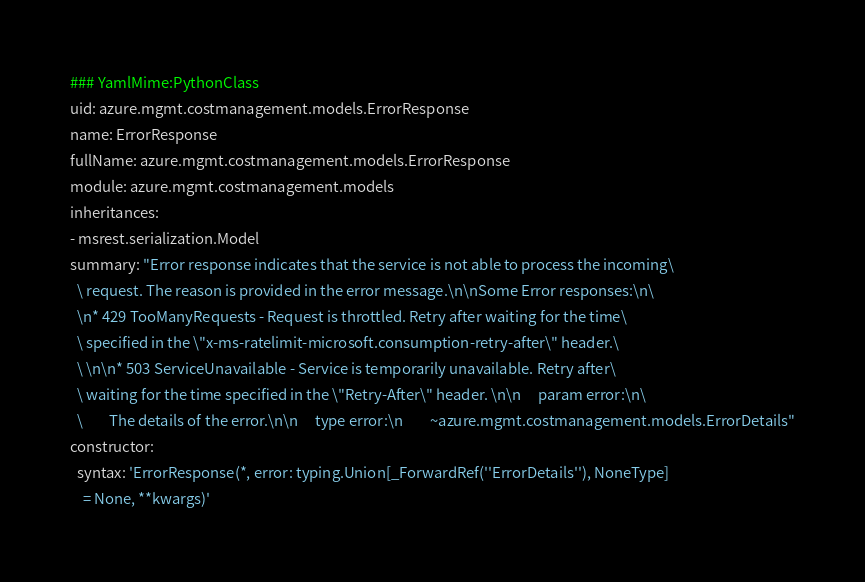<code> <loc_0><loc_0><loc_500><loc_500><_YAML_>### YamlMime:PythonClass
uid: azure.mgmt.costmanagement.models.ErrorResponse
name: ErrorResponse
fullName: azure.mgmt.costmanagement.models.ErrorResponse
module: azure.mgmt.costmanagement.models
inheritances:
- msrest.serialization.Model
summary: "Error response indicates that the service is not able to process the incoming\
  \ request. The reason is provided in the error message.\n\nSome Error responses:\n\
  \n* 429 TooManyRequests - Request is throttled. Retry after waiting for the time\
  \ specified in the \"x-ms-ratelimit-microsoft.consumption-retry-after\" header.\
  \ \n\n* 503 ServiceUnavailable - Service is temporarily unavailable. Retry after\
  \ waiting for the time specified in the \"Retry-After\" header. \n\n     param error:\n\
  \        The details of the error.\n\n     type error:\n        ~azure.mgmt.costmanagement.models.ErrorDetails"
constructor:
  syntax: 'ErrorResponse(*, error: typing.Union[_ForwardRef(''ErrorDetails''), NoneType]
    = None, **kwargs)'
</code> 